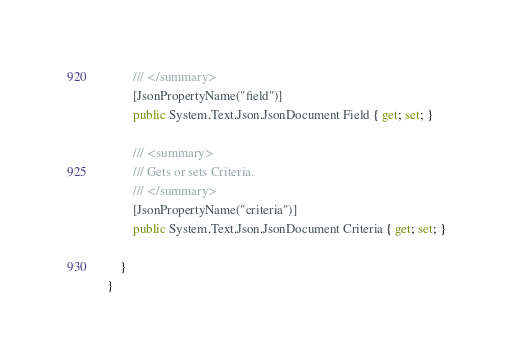<code> <loc_0><loc_0><loc_500><loc_500><_C#_>        /// </summary>
        [JsonPropertyName("field")]
        public System.Text.Json.JsonDocument Field { get; set; }
    
        /// <summary>
        /// Gets or sets Criteria.
        /// </summary>
        [JsonPropertyName("criteria")]
        public System.Text.Json.JsonDocument Criteria { get; set; }
    
    }
}
</code> 